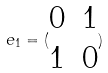<formula> <loc_0><loc_0><loc_500><loc_500>e _ { 1 } = ( \begin{matrix} 0 & 1 \\ 1 & 0 \end{matrix} )</formula> 